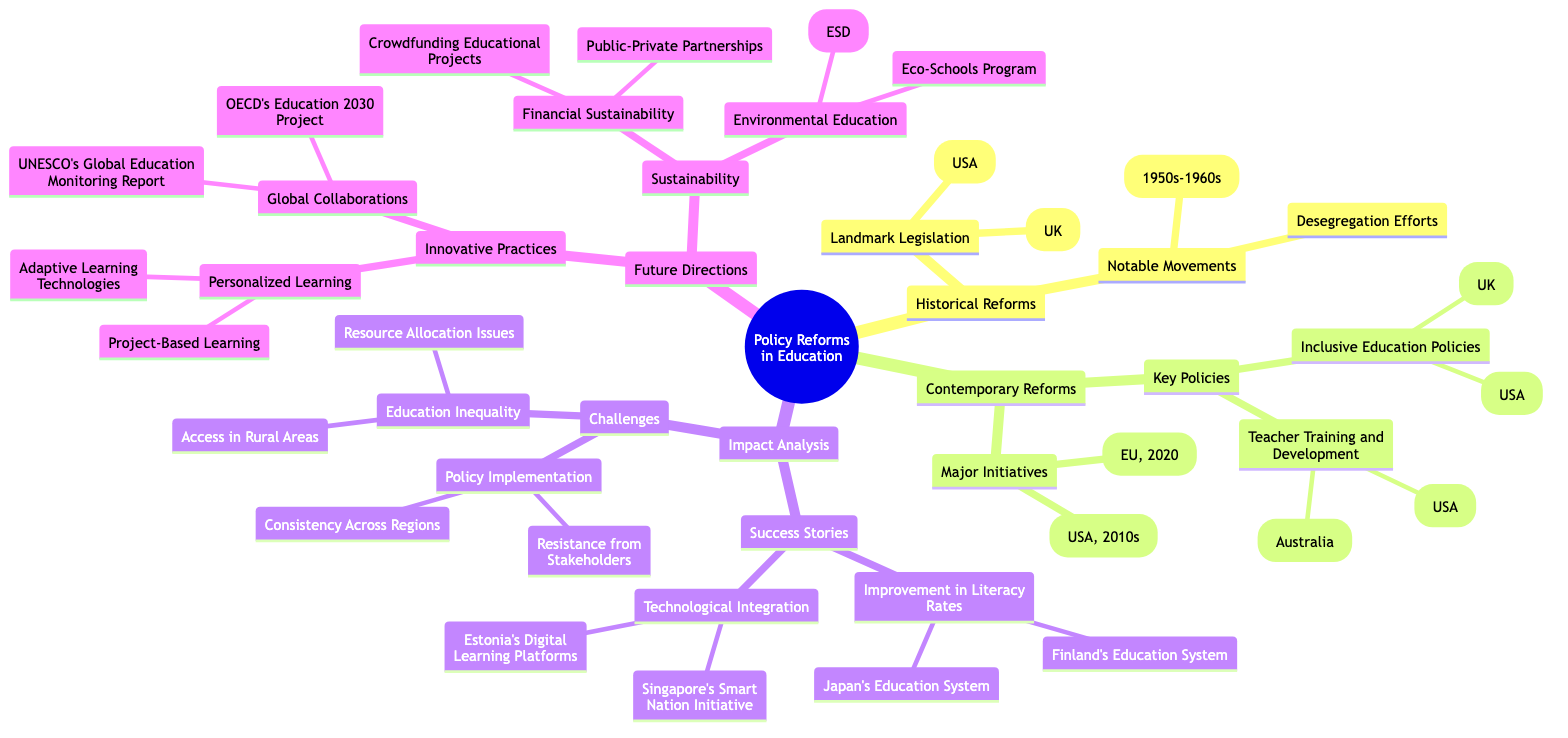What is the central theme of the mind map? The central theme is explicitly mentioned at the top of the mind map, which is "Policy Reforms in Education: Analyzing Past and Present Efforts to Improve Education Systems."
Answer: Policy Reforms in Education: Analyzing Past and Present Efforts to Improve Education Systems How many main branches are present in the mind map? The main branches are visible directly from the diagram, and there are four main branches listed: Historical Reforms, Contemporary Reforms, Impact Analysis, and Future Directions. Counting these gives a total of four.
Answer: 4 Which landmark legislation relates to the USA in historical reforms? In the sub-branch titled "Landmark Legislation" under "Historical Reforms," specifically for the USA, the "Elementary and Secondary Education Act of 1965" is mentioned.
Answer: Elementary and Secondary Education Act of 1965 (USA) What notable movement occurred in the 1950s-1960s? Under the "Notable Movements" branch in "Historical Reforms," the diagram states the "Civil Rights Movement (1950s-1960s)" as an example of a notable movement.
Answer: Civil Rights Movement (1950s-1960s) List one major initiative in contemporary reforms. Within the "Major Initiatives" sub-branch under "Contemporary Reforms," both "Common Core State Standards (USA, 2010s)" and "Digital Education Action Plan (EU, 2020)" are provided as examples; listing either serves as a valid answer.
Answer: Common Core State Standards (USA, 2010s) What challenges are related to education inequality according to the mind map? In the "Challenges" sub-branch of the "Impact Analysis" section, "Education Inequality" lists "Resource Allocation Issues" and "Access in Rural Areas," specifying challenges directly related to education inequality.
Answer: Resource Allocation Issues Which future direction focuses on innovative practices? The branch titled "Innovative Practices" is specifically mentioned under the "Future Directions" category, indicating a focus area for future reforms in education systems.
Answer: Innovative Practices How many key policies are listed in contemporary reforms? Under the "Key Policies" sub-branch in "Contemporary Reforms," there are two main categories: "Inclusive Education Policies" and "Teacher Training and Development." Thus, counting these categories indicates there are two.
Answer: 2 Name one initiative that relates to sustainability in education. In the "Sustainability" section of "Future Directions," two specific initiatives are highlighted: "Environmental Education" and "Financial Sustainability." Listing either of these represents a valid answer.
Answer: Environmental Education 